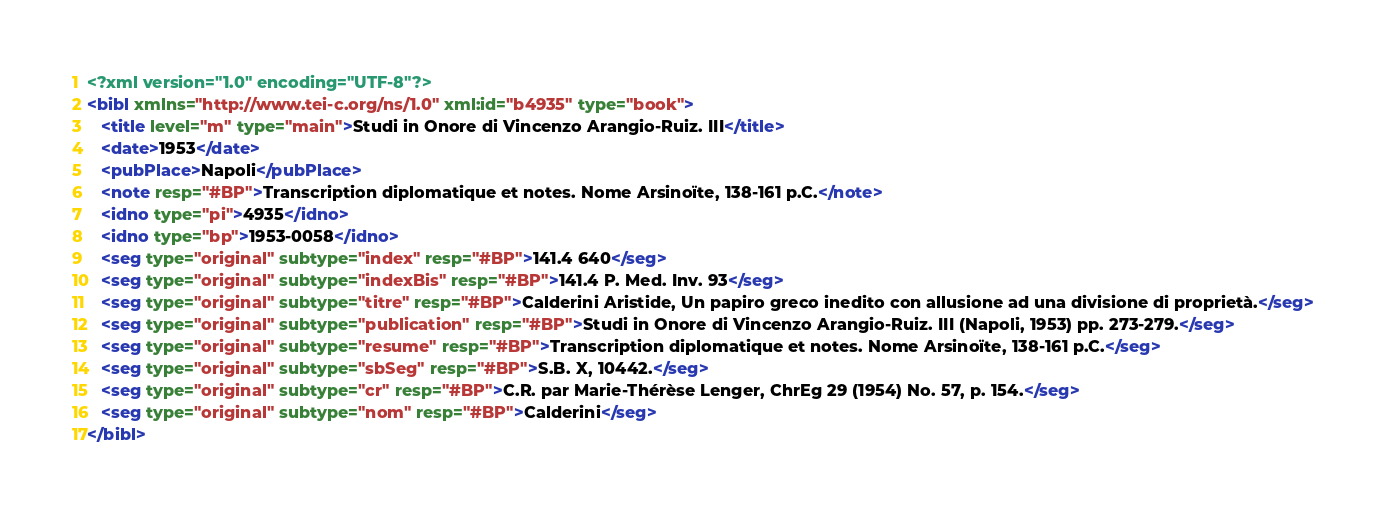<code> <loc_0><loc_0><loc_500><loc_500><_XML_><?xml version="1.0" encoding="UTF-8"?>
<bibl xmlns="http://www.tei-c.org/ns/1.0" xml:id="b4935" type="book">
   <title level="m" type="main">Studi in Onore di Vincenzo Arangio-Ruiz. III</title>
   <date>1953</date>
   <pubPlace>Napoli</pubPlace>
   <note resp="#BP">Transcription diplomatique et notes. Nome Arsinoïte, 138-161 p.C.</note>
   <idno type="pi">4935</idno>
   <idno type="bp">1953-0058</idno>
   <seg type="original" subtype="index" resp="#BP">141.4 640</seg>
   <seg type="original" subtype="indexBis" resp="#BP">141.4 P. Med. Inv. 93</seg>
   <seg type="original" subtype="titre" resp="#BP">Calderini Aristide, Un papiro greco inedito con allusione ad una divisione di proprietà.</seg>
   <seg type="original" subtype="publication" resp="#BP">Studi in Onore di Vincenzo Arangio-Ruiz. III (Napoli, 1953) pp. 273-279.</seg>
   <seg type="original" subtype="resume" resp="#BP">Transcription diplomatique et notes. Nome Arsinoïte, 138-161 p.C.</seg>
   <seg type="original" subtype="sbSeg" resp="#BP">S.B. X, 10442.</seg>
   <seg type="original" subtype="cr" resp="#BP">C.R. par Marie-Thérèse Lenger, ChrEg 29 (1954) No. 57, p. 154.</seg>
   <seg type="original" subtype="nom" resp="#BP">Calderini</seg>
</bibl></code> 